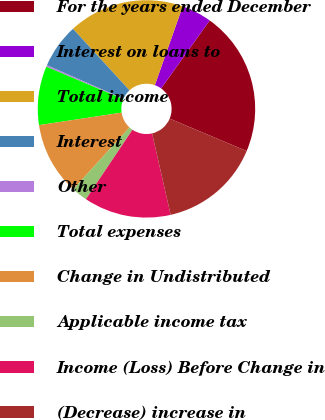Convert chart to OTSL. <chart><loc_0><loc_0><loc_500><loc_500><pie_chart><fcel>For the years ended December<fcel>Interest on loans to<fcel>Total income<fcel>Interest<fcel>Other<fcel>Total expenses<fcel>Change in Undistributed<fcel>Applicable income tax<fcel>Income (Loss) Before Change in<fcel>(Decrease) increase in<nl><fcel>21.46%<fcel>4.48%<fcel>17.22%<fcel>6.6%<fcel>0.24%<fcel>8.73%<fcel>10.85%<fcel>2.36%<fcel>12.97%<fcel>15.09%<nl></chart> 